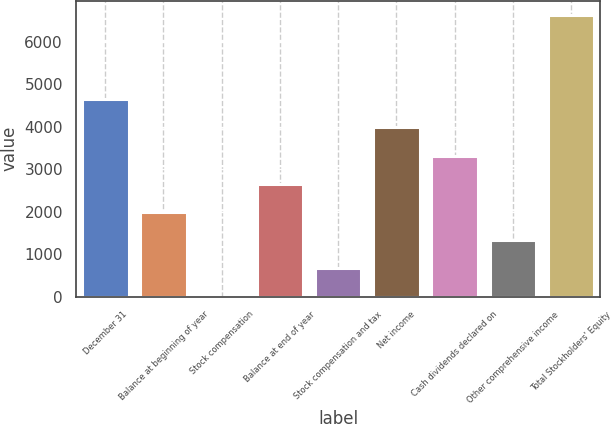Convert chart to OTSL. <chart><loc_0><loc_0><loc_500><loc_500><bar_chart><fcel>December 31<fcel>Balance at beginning of year<fcel>Stock compensation<fcel>Balance at end of year<fcel>Stock compensation and tax<fcel>Net income<fcel>Cash dividends declared on<fcel>Other comprehensive income<fcel>Total Stockholders' Equity<nl><fcel>4644.28<fcel>1990.92<fcel>0.9<fcel>2654.26<fcel>664.24<fcel>3980.94<fcel>3317.6<fcel>1327.58<fcel>6634.3<nl></chart> 